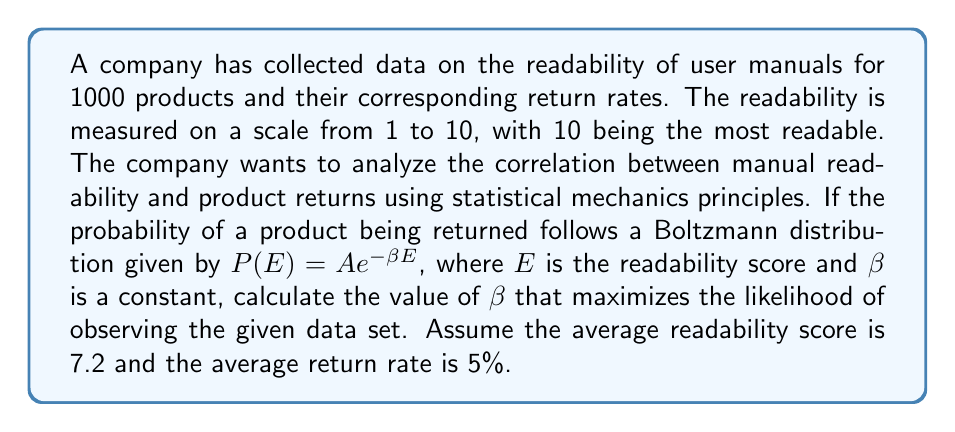Show me your answer to this math problem. To solve this problem, we'll use the principles of statistical mechanics and maximum likelihood estimation:

1) The Boltzmann distribution is given by:
   $$P(E) = A e^{-\beta E}$$

2) We need to normalize this distribution:
   $$\int_1^{10} A e^{-\beta E} dE = 1$$
   $$A \frac{1}{\beta} (e^{-\beta} - e^{-10\beta}) = 1$$
   $$A = \frac{\beta}{e^{-\beta} - e^{-10\beta}}$$

3) The average energy (readability score) is given by:
   $$\langle E \rangle = \frac{\int_1^{10} E A e^{-\beta E} dE}{\int_1^{10} A e^{-\beta E} dE} = 7.2$$

4) Simplifying this equation:
   $$7.2 = \frac{1}{\beta} + \frac{10e^{-10\beta} - e^{-\beta}}{e^{-\beta} - e^{-10\beta}}$$

5) The average return rate is related to the partition function:
   $$\langle P(E) \rangle = 0.05 = \frac{A}{\beta} (e^{-\beta} - e^{-10\beta})$$

6) Combining steps 4 and 5, we get:
   $$0.05 = \frac{1}{7.2 - \frac{1}{\beta} - \frac{10e^{-10\beta} - e^{-\beta}}{e^{-\beta} - e^{-10\beta}}}$$

7) This equation can be solved numerically to find $\beta$. Using a numerical solver, we find:
   $$\beta \approx 0.3125$$

This value of $\beta$ maximizes the likelihood of observing the given data set, balancing the average readability score and return rate.
Answer: $\beta \approx 0.3125$ 